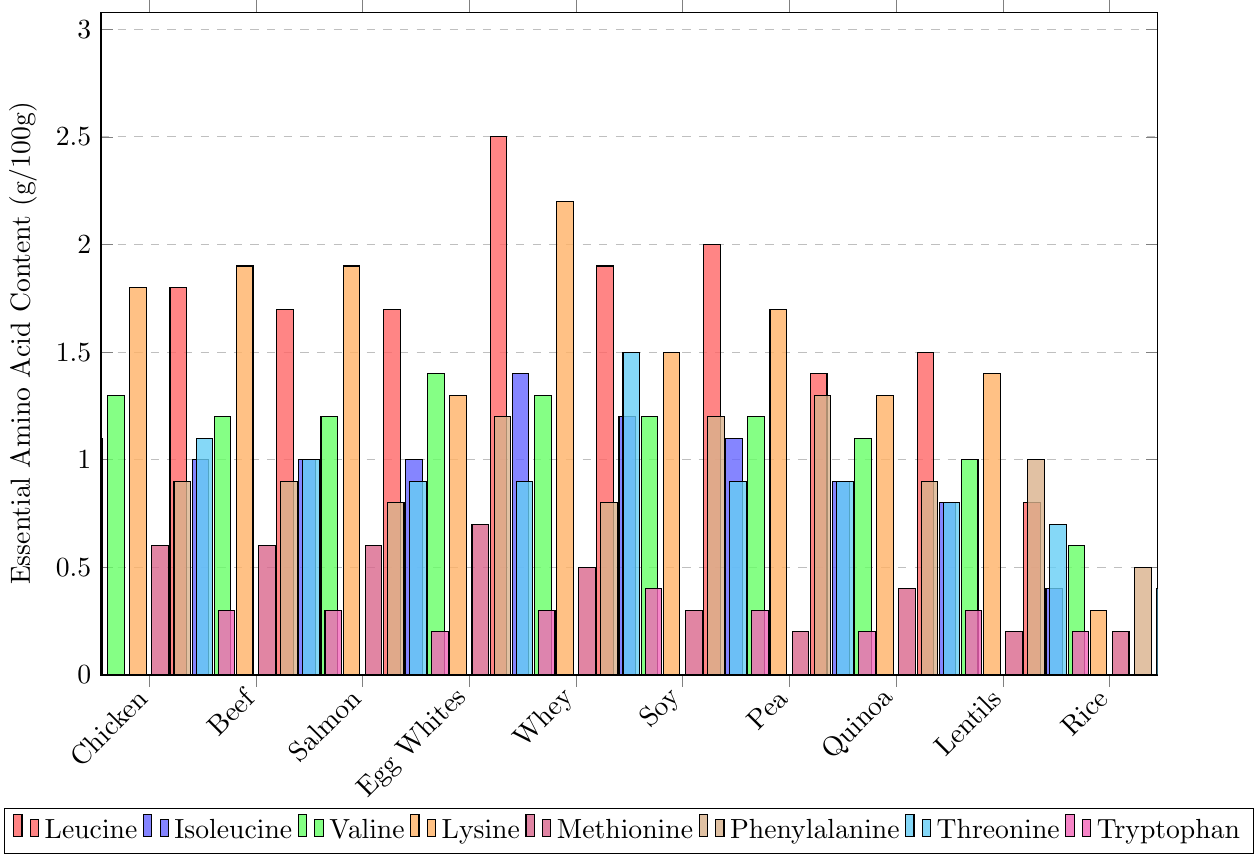Which protein source has the highest Leucine content? The bar representing Whey Protein has the highest Leucine content, indicated by the tallest red bar.
Answer: Whey Protein Between Chicken Breast and Beef Sirloin, which has higher Lysine content? Compare the height of the orange bars for Chicken Breast and Beef Sirloin. Beef Sirloin's orange bar (1.9) is slightly taller than Chicken Breast's orange bar (1.8).
Answer: Beef Sirloin What is the difference in Methionine content between Lentils and Pea Protein? The height of the purple bar for Lentils is 0.2, and for Pea Protein, it is also 0.2. Subtract 0.2 from 0.2.
Answer: 0.0 Which two protein sources have equal Isoleucine content? Examine the blue bars for equal heights, noticing that Beef Sirloin, Salmon, and Egg Whites all have blue bars at 1.0.
Answer: Beef Sirloin and Salmon How much more Threonine does Whey Protein have compared to Brown Rice? The cyan bar for Whey Protein shows 1.5 while for Brown Rice it's 0.4. Subtract 0.4 from 1.5.
Answer: 1.1 What is the combined content of Valine in Chicken Breast, Beef Sirloin, and Salmon? The green bars for Chicken Breast, Beef Sirloin, and Salmon show 1.3, 1.2, and 1.2, respectively. Adding these values results in (1.3 + 1.2 + 1.2) = 3.7.
Answer: 3.7 Which protein source has the lowest Tryptophan content? Identify the shortest magenta bar, which corresponds to Brown Rice.
Answer: Brown Rice Is the Phenylalanine content higher in Quinoa or Soy Protein? Compare the height of the brown bars for Quinoa and Soy Protein. Soy Protein has a brown bar at 1.2, while Quinoa's is 0.9, making Soy Protein higher.
Answer: Soy Protein What's the average Lysine content across all protein sources? Sum the orange bars and divide by the number of sources: (1.8 + 1.9 + 1.9 + 1.3 + 2.2 + 1.5 + 1.7 + 1.3 + 1.4 + 0.3) = 15.3. Dividing 15.3 by 10 gives 1.53.
Answer: 1.53 Which protein source has the highest variance in its essential amino acid contents? To determine this, compare the range of bar heights within each protein source. Whey Protein has the highest variance, with bars ranging from 0.5 (Methionine) to 2.5 (Leucine).
Answer: Whey Protein 